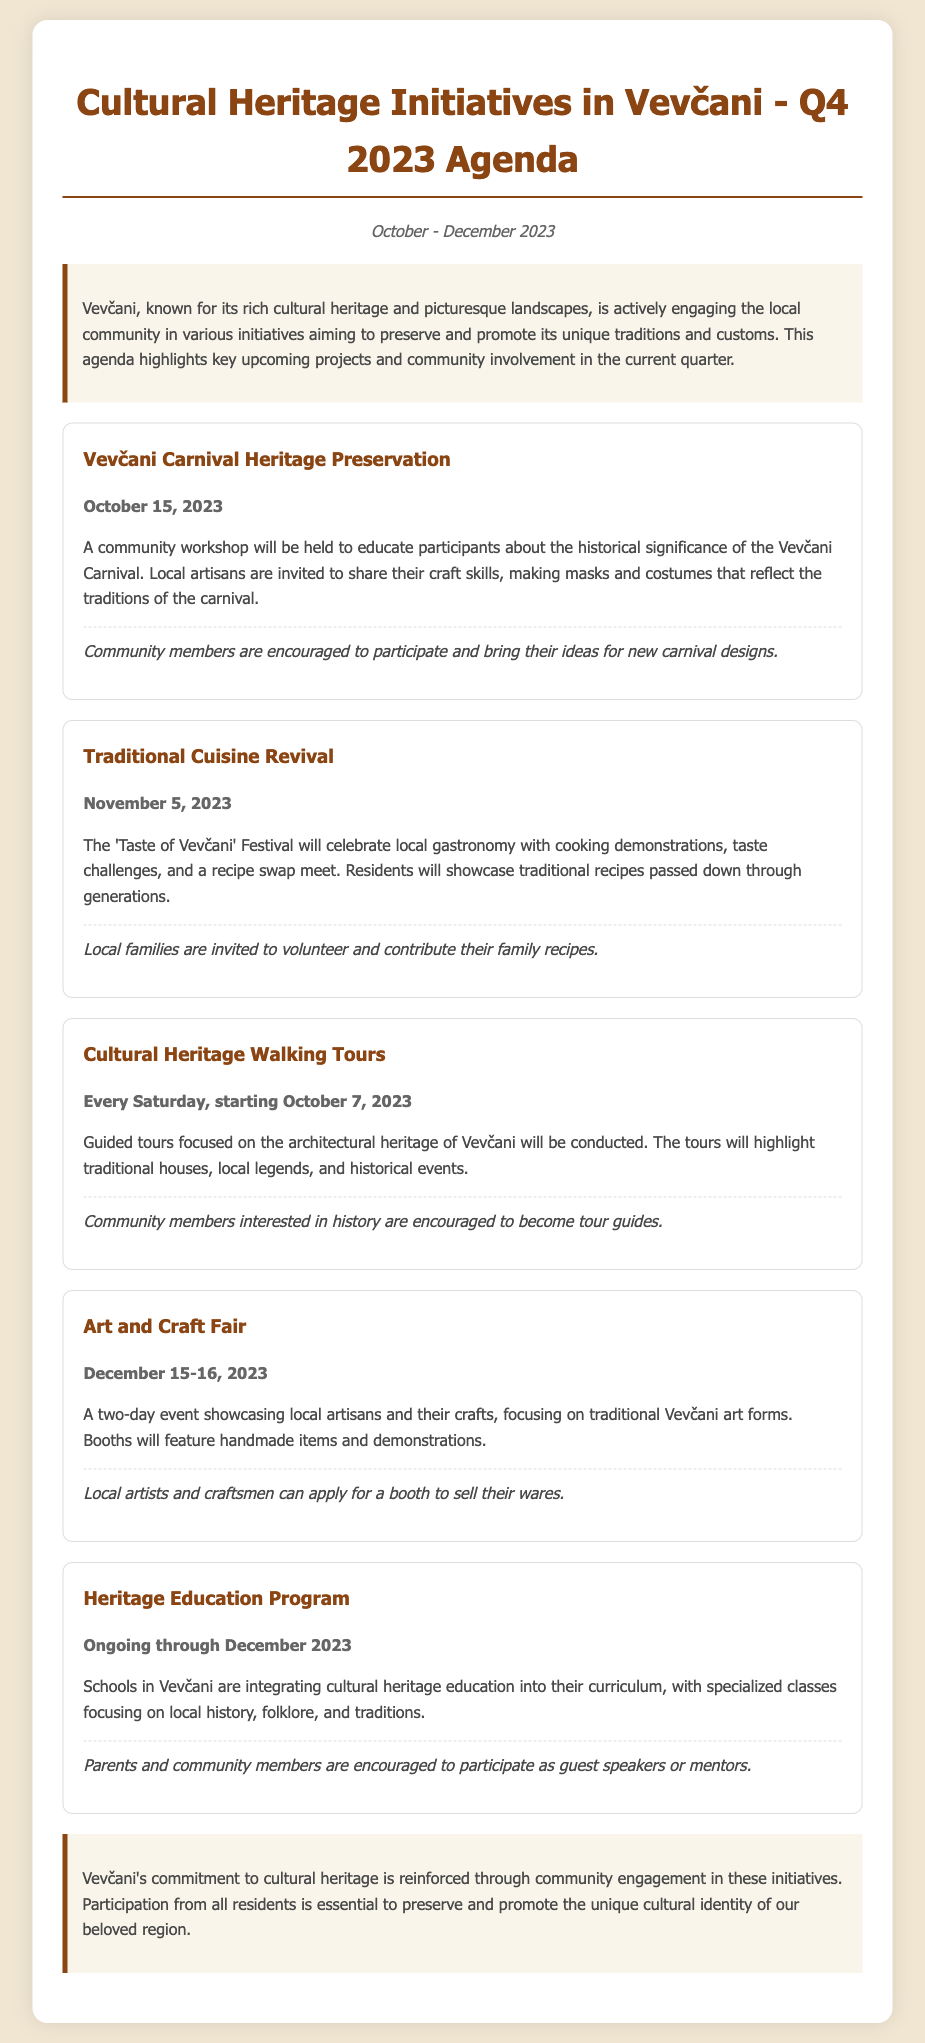What is the title of the agenda? The title is clearly stated at the beginning of the document, providing the main subject of the agenda.
Answer: Cultural Heritage Initiatives in Vevčani - Q4 2023 Agenda What are the dates of the quarter covered in the agenda? The dates are specified in the introduction section, indicating the period the agenda pertains to.
Answer: October - December 2023 When is the Vevčani Carnival Heritage Preservation workshop scheduled? The date is indicated right below the title of the specific initiative in the document.
Answer: October 15, 2023 What is the name of the festival that celebrates local gastronomy? The festival's name is mentioned under the Traditional Cuisine Revival initiative, highlighting its purpose.
Answer: Taste of Vevčani How often do the Cultural Heritage Walking Tours occur? The frequency is mentioned in the overview of the related initiative, indicating how regular the tours will be.
Answer: Every Saturday What theme do the booths at the Art and Craft Fair focus on? The theme is outlined briefly in the description of the fair, illustrating its main attraction.
Answer: Traditional Vevčani art forms Which community members are encouraged to participate as guest speakers in the Heritage Education Program? The specific group is mentioned at the end of the initiative description, indicating who can contribute.
Answer: Parents and community members What type of skills will be shared by local artisans during the carnival workshop? The skills are specified in the description of the workshop, indicating the activities involved.
Answer: Craft skills What is the main purpose of the initiatives listed in the agenda? The overall aim is mentioned in the conclusion, summarizing the intent behind the various activities.
Answer: Preserve and promote cultural heritage 